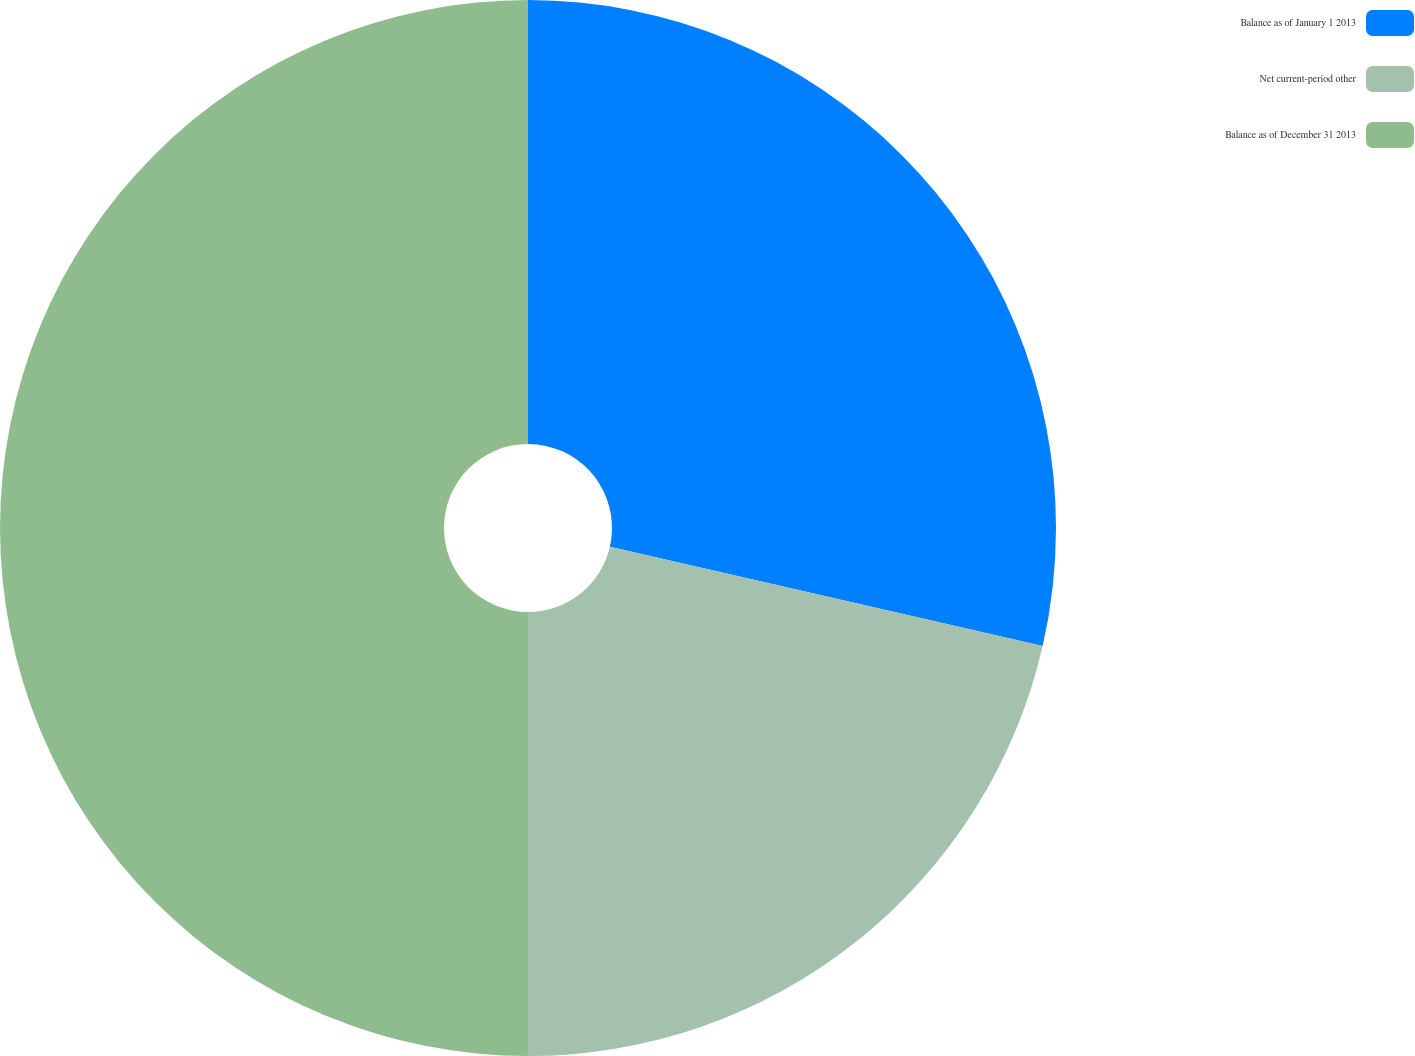<chart> <loc_0><loc_0><loc_500><loc_500><pie_chart><fcel>Balance as of January 1 2013<fcel>Net current-period other<fcel>Balance as of December 31 2013<nl><fcel>28.59%<fcel>21.41%<fcel>50.0%<nl></chart> 